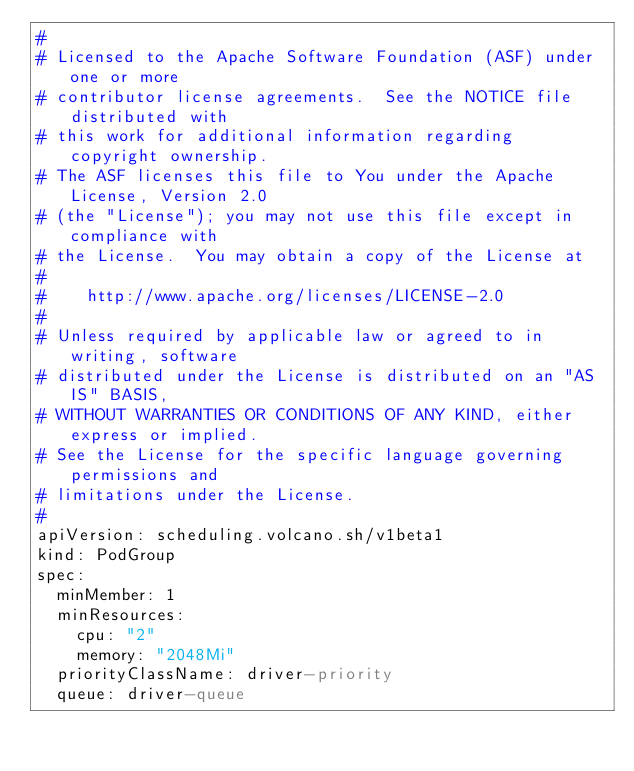Convert code to text. <code><loc_0><loc_0><loc_500><loc_500><_YAML_>#
# Licensed to the Apache Software Foundation (ASF) under one or more
# contributor license agreements.  See the NOTICE file distributed with
# this work for additional information regarding copyright ownership.
# The ASF licenses this file to You under the Apache License, Version 2.0
# (the "License"); you may not use this file except in compliance with
# the License.  You may obtain a copy of the License at
#
#    http://www.apache.org/licenses/LICENSE-2.0
#
# Unless required by applicable law or agreed to in writing, software
# distributed under the License is distributed on an "AS IS" BASIS,
# WITHOUT WARRANTIES OR CONDITIONS OF ANY KIND, either express or implied.
# See the License for the specific language governing permissions and
# limitations under the License.
#
apiVersion: scheduling.volcano.sh/v1beta1
kind: PodGroup
spec:
  minMember: 1
  minResources:
    cpu: "2"
    memory: "2048Mi"
  priorityClassName: driver-priority
  queue: driver-queue
</code> 